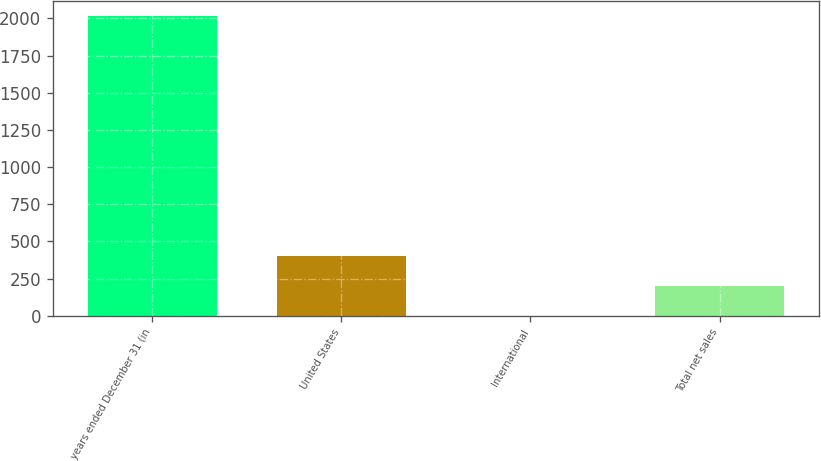Convert chart. <chart><loc_0><loc_0><loc_500><loc_500><bar_chart><fcel>years ended December 31 (in<fcel>United States<fcel>International<fcel>Total net sales<nl><fcel>2016<fcel>404<fcel>1<fcel>202.5<nl></chart> 